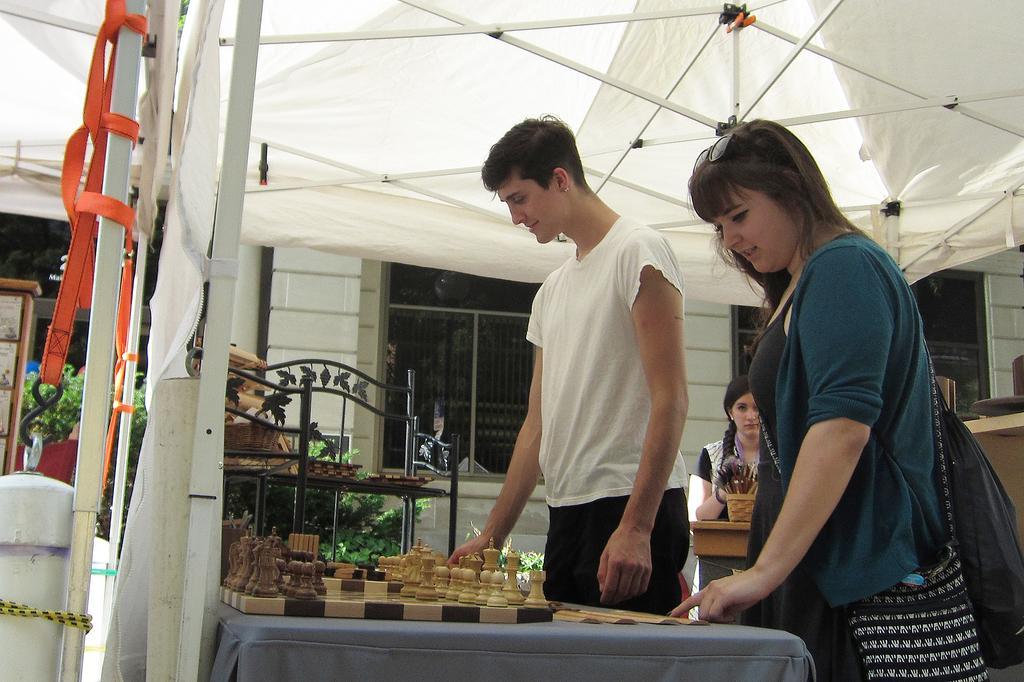Can you describe this image briefly? In this picture there is a boy wearing white color t-shirt, standing near the chess board which is placed on the table. Beside there is a woman wearing a blue color jacket, she is looking to the chess board. Behind there is a house and a glass window. Above there is a white color canopy shed. 